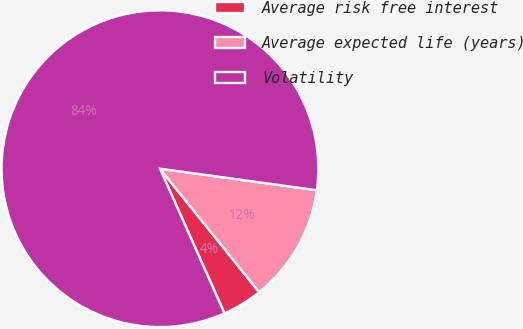Convert chart. <chart><loc_0><loc_0><loc_500><loc_500><pie_chart><fcel>Average risk free interest<fcel>Average expected life (years)<fcel>Volatility<nl><fcel>4.09%<fcel>12.06%<fcel>83.85%<nl></chart> 